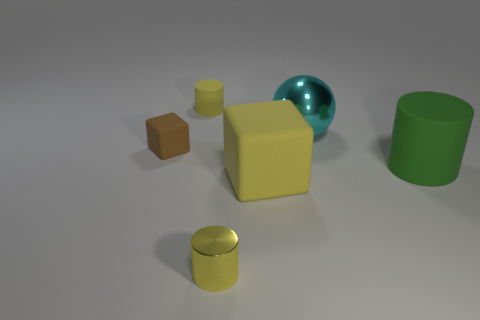How would you describe the overall scene and the arrangement of the objects in the image? The scene presents a simple 3D composition of various geometric shapes arranged on a flat surface. The objects are spaced out, and their sizes vary, creating a sense of depth and dimensionality. The arrangement could be seen as an abstract art piece or a visual composition exercise for studying form and shadow. 